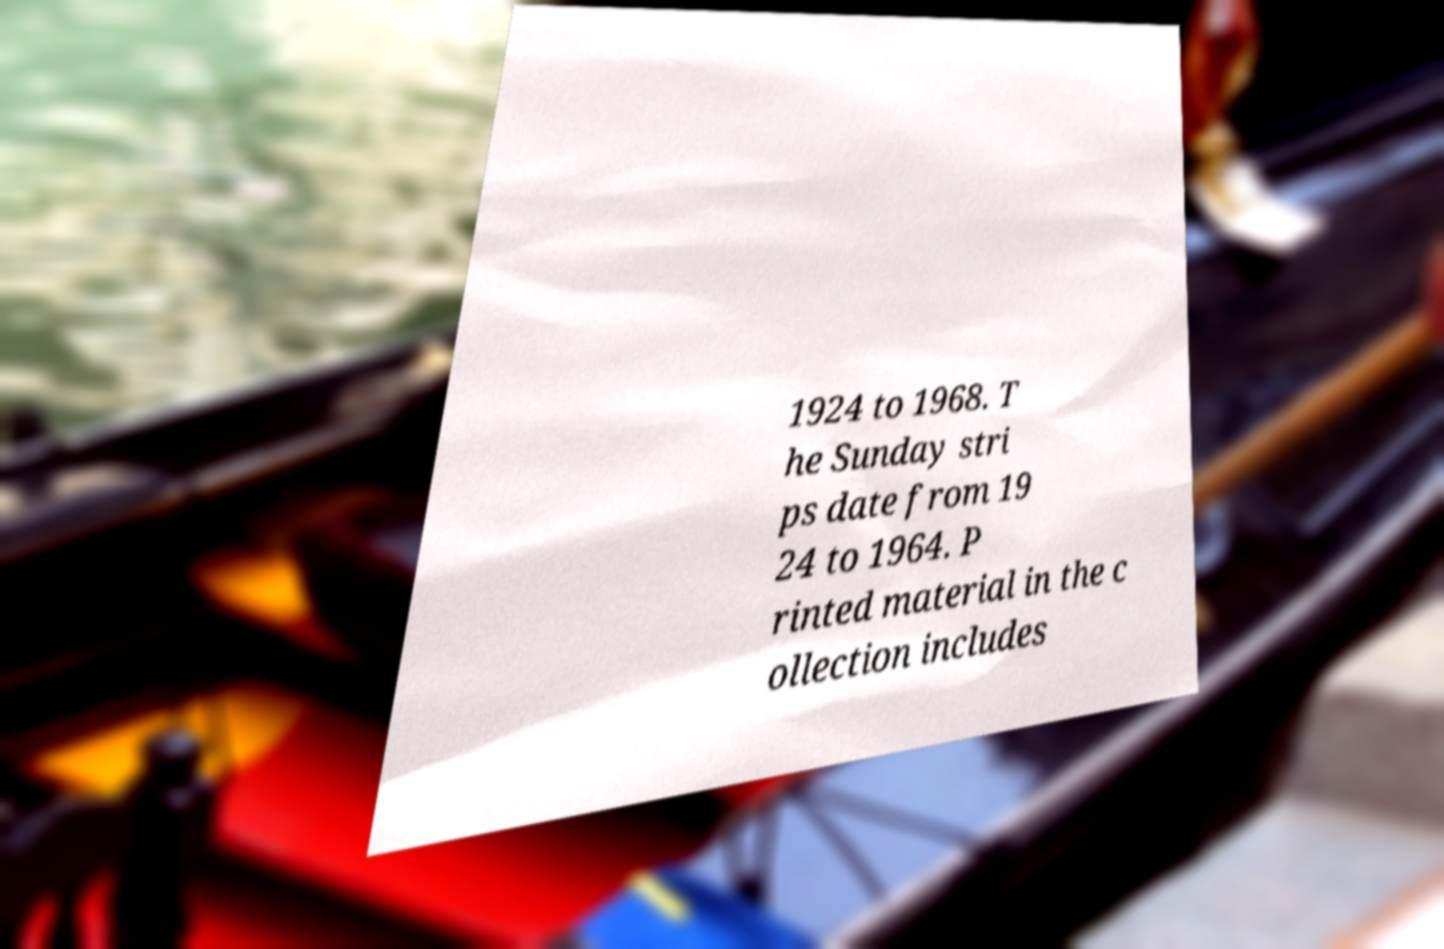Please identify and transcribe the text found in this image. 1924 to 1968. T he Sunday stri ps date from 19 24 to 1964. P rinted material in the c ollection includes 